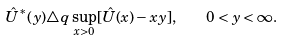<formula> <loc_0><loc_0><loc_500><loc_500>\hat { U } ^ { * } ( y ) \triangle q \sup _ { x > 0 } [ \hat { U } ( x ) - x y ] , \quad 0 < y < \infty .</formula> 